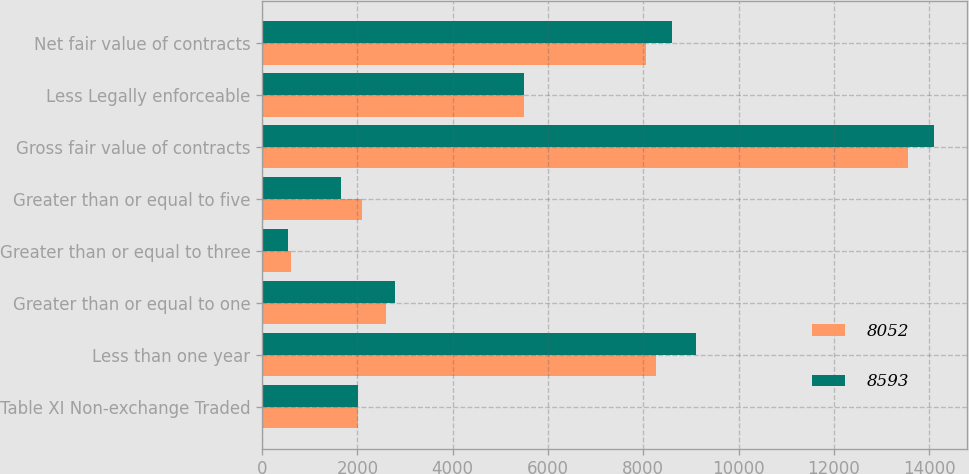Convert chart. <chart><loc_0><loc_0><loc_500><loc_500><stacked_bar_chart><ecel><fcel>Table XI Non-exchange Traded<fcel>Less than one year<fcel>Greater than or equal to one<fcel>Greater than or equal to three<fcel>Greater than or equal to five<fcel>Gross fair value of contracts<fcel>Less Legally enforceable<fcel>Net fair value of contracts<nl><fcel>8052<fcel>2014<fcel>8262<fcel>2598<fcel>599<fcel>2099<fcel>13558<fcel>5506<fcel>8052<nl><fcel>8593<fcel>2014<fcel>9114<fcel>2798<fcel>533<fcel>1654<fcel>14099<fcel>5506<fcel>8593<nl></chart> 